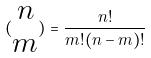<formula> <loc_0><loc_0><loc_500><loc_500>( \begin{matrix} n \\ m \end{matrix} ) = \frac { n ! } { m ! ( n - m ) ! }</formula> 